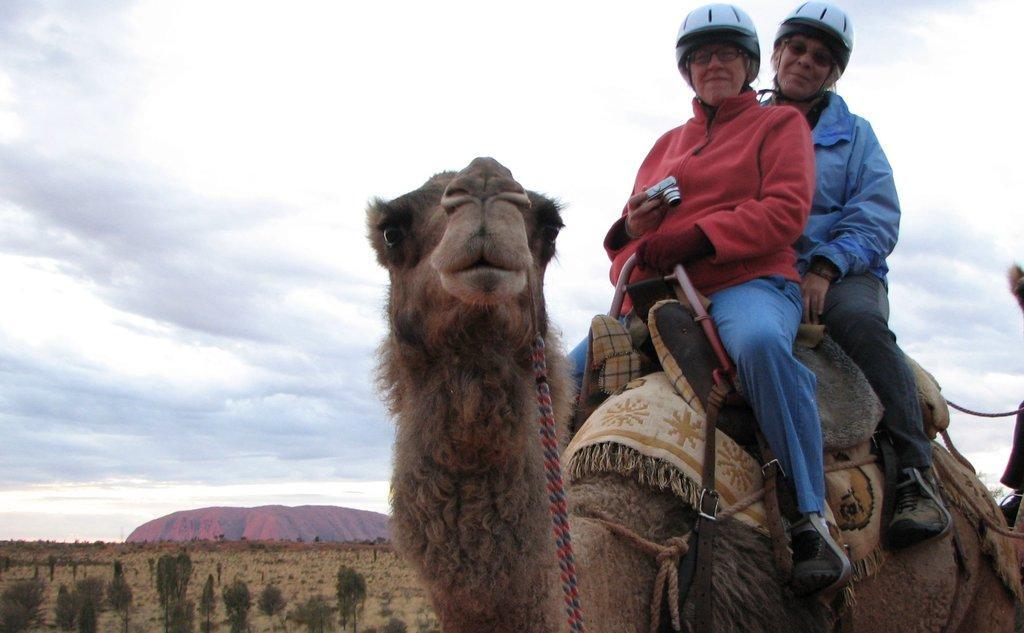Can you describe this image briefly? Two women are sitting on the camel, this woman wore a red color sweater and this woman wore a blue color sweater. At the top it's a cloudy sky. 